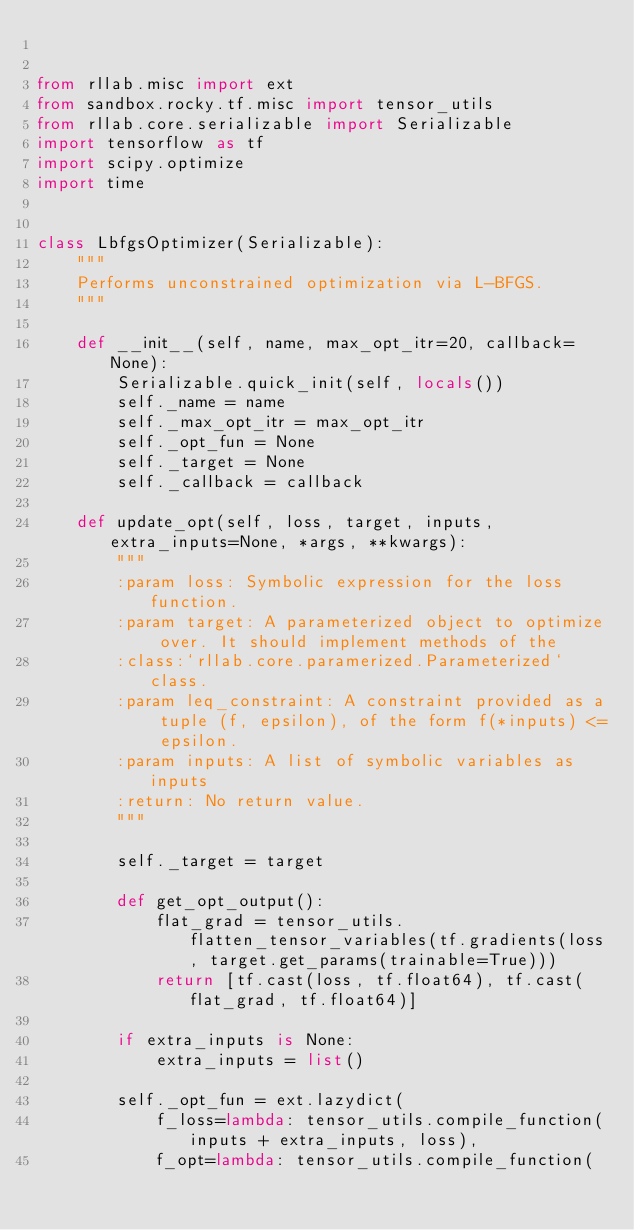Convert code to text. <code><loc_0><loc_0><loc_500><loc_500><_Python_>

from rllab.misc import ext
from sandbox.rocky.tf.misc import tensor_utils
from rllab.core.serializable import Serializable
import tensorflow as tf
import scipy.optimize
import time


class LbfgsOptimizer(Serializable):
    """
    Performs unconstrained optimization via L-BFGS.
    """

    def __init__(self, name, max_opt_itr=20, callback=None):
        Serializable.quick_init(self, locals())
        self._name = name
        self._max_opt_itr = max_opt_itr
        self._opt_fun = None
        self._target = None
        self._callback = callback

    def update_opt(self, loss, target, inputs, extra_inputs=None, *args, **kwargs):
        """
        :param loss: Symbolic expression for the loss function.
        :param target: A parameterized object to optimize over. It should implement methods of the
        :class:`rllab.core.paramerized.Parameterized` class.
        :param leq_constraint: A constraint provided as a tuple (f, epsilon), of the form f(*inputs) <= epsilon.
        :param inputs: A list of symbolic variables as inputs
        :return: No return value.
        """

        self._target = target

        def get_opt_output():
            flat_grad = tensor_utils.flatten_tensor_variables(tf.gradients(loss, target.get_params(trainable=True)))
            return [tf.cast(loss, tf.float64), tf.cast(flat_grad, tf.float64)]

        if extra_inputs is None:
            extra_inputs = list()

        self._opt_fun = ext.lazydict(
            f_loss=lambda: tensor_utils.compile_function(inputs + extra_inputs, loss),
            f_opt=lambda: tensor_utils.compile_function(</code> 